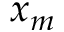Convert formula to latex. <formula><loc_0><loc_0><loc_500><loc_500>x _ { m }</formula> 